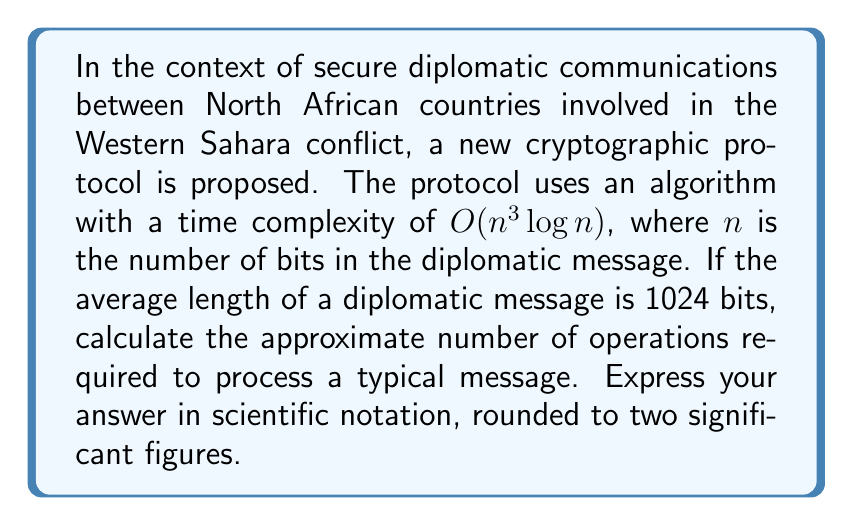Can you answer this question? To solve this problem, we'll follow these steps:

1) The time complexity of the algorithm is $O(n^3 \log n)$, where $n$ is the number of bits in the message.

2) We're given that the average message length is 1024 bits, so $n = 1024$.

3) Let's substitute this into our complexity function:
   $f(n) = n^3 \log n = 1024^3 \log 1024$

4) First, let's calculate $1024^3$:
   $1024^3 = (2^{10})^3 = 2^{30} = 1,073,741,824$

5) Now, let's calculate $\log 1024$:
   $\log 1024 = \log 2^{10} = 10$ (assuming base-2 logarithm, which is common in computer science)

6) Multiplying these together:
   $1,073,741,824 * 10 = 10,737,418,240$

7) This represents the approximate number of operations required to process a typical message.

8) Expressing this in scientific notation with two significant figures:
   $10,737,418,240 \approx 1.1 * 10^{10}$
Answer: $1.1 * 10^{10}$ 